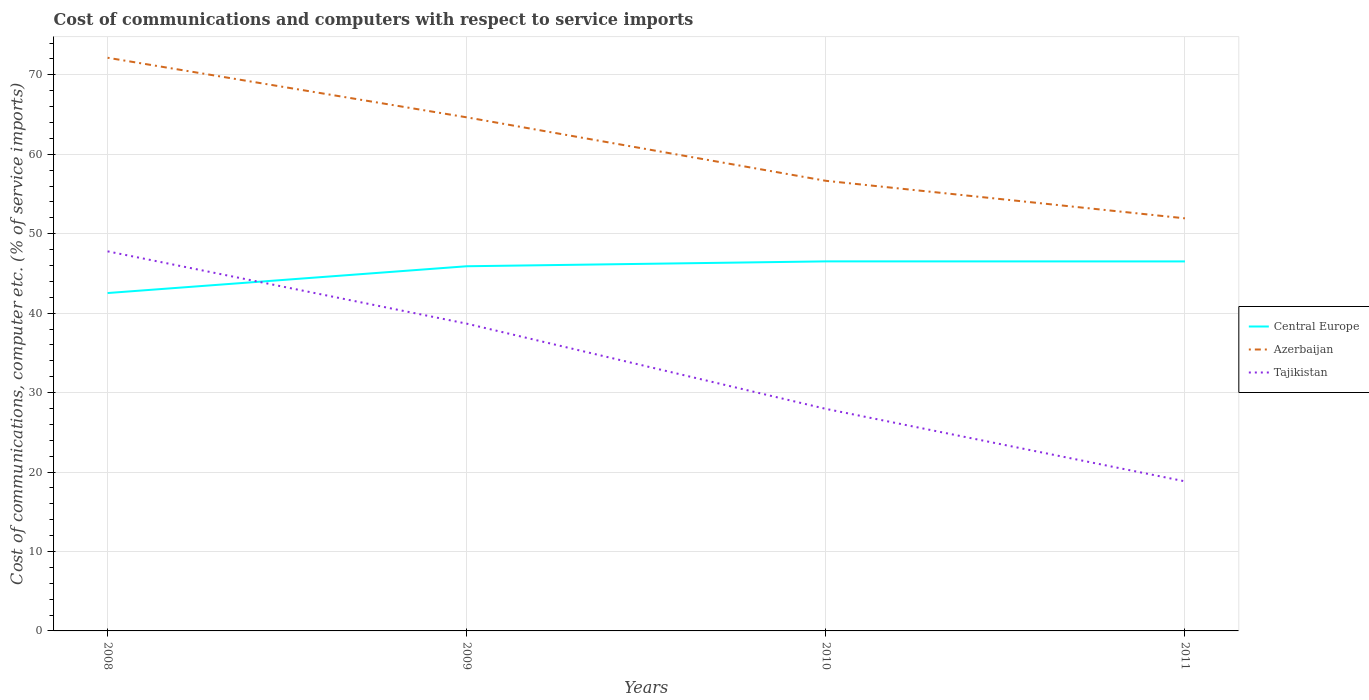How many different coloured lines are there?
Provide a succinct answer. 3. Across all years, what is the maximum cost of communications and computers in Azerbaijan?
Your answer should be very brief. 51.94. In which year was the cost of communications and computers in Tajikistan maximum?
Your answer should be compact. 2011. What is the total cost of communications and computers in Tajikistan in the graph?
Make the answer very short. 10.73. What is the difference between the highest and the second highest cost of communications and computers in Tajikistan?
Provide a succinct answer. 28.95. What is the difference between the highest and the lowest cost of communications and computers in Central Europe?
Give a very brief answer. 3. Is the cost of communications and computers in Central Europe strictly greater than the cost of communications and computers in Tajikistan over the years?
Ensure brevity in your answer.  No. Are the values on the major ticks of Y-axis written in scientific E-notation?
Offer a terse response. No. Does the graph contain any zero values?
Offer a very short reply. No. Does the graph contain grids?
Give a very brief answer. Yes. Where does the legend appear in the graph?
Make the answer very short. Center right. How are the legend labels stacked?
Provide a short and direct response. Vertical. What is the title of the graph?
Offer a terse response. Cost of communications and computers with respect to service imports. What is the label or title of the Y-axis?
Give a very brief answer. Cost of communications, computer etc. (% of service imports). What is the Cost of communications, computer etc. (% of service imports) of Central Europe in 2008?
Offer a terse response. 42.53. What is the Cost of communications, computer etc. (% of service imports) of Azerbaijan in 2008?
Ensure brevity in your answer.  72.15. What is the Cost of communications, computer etc. (% of service imports) in Tajikistan in 2008?
Provide a succinct answer. 47.78. What is the Cost of communications, computer etc. (% of service imports) in Central Europe in 2009?
Give a very brief answer. 45.9. What is the Cost of communications, computer etc. (% of service imports) of Azerbaijan in 2009?
Your response must be concise. 64.65. What is the Cost of communications, computer etc. (% of service imports) of Tajikistan in 2009?
Give a very brief answer. 38.68. What is the Cost of communications, computer etc. (% of service imports) of Central Europe in 2010?
Offer a very short reply. 46.52. What is the Cost of communications, computer etc. (% of service imports) in Azerbaijan in 2010?
Provide a short and direct response. 56.66. What is the Cost of communications, computer etc. (% of service imports) in Tajikistan in 2010?
Keep it short and to the point. 27.95. What is the Cost of communications, computer etc. (% of service imports) in Central Europe in 2011?
Your answer should be very brief. 46.51. What is the Cost of communications, computer etc. (% of service imports) in Azerbaijan in 2011?
Give a very brief answer. 51.94. What is the Cost of communications, computer etc. (% of service imports) in Tajikistan in 2011?
Your answer should be very brief. 18.83. Across all years, what is the maximum Cost of communications, computer etc. (% of service imports) in Central Europe?
Ensure brevity in your answer.  46.52. Across all years, what is the maximum Cost of communications, computer etc. (% of service imports) in Azerbaijan?
Offer a very short reply. 72.15. Across all years, what is the maximum Cost of communications, computer etc. (% of service imports) of Tajikistan?
Make the answer very short. 47.78. Across all years, what is the minimum Cost of communications, computer etc. (% of service imports) of Central Europe?
Your response must be concise. 42.53. Across all years, what is the minimum Cost of communications, computer etc. (% of service imports) of Azerbaijan?
Your response must be concise. 51.94. Across all years, what is the minimum Cost of communications, computer etc. (% of service imports) of Tajikistan?
Make the answer very short. 18.83. What is the total Cost of communications, computer etc. (% of service imports) in Central Europe in the graph?
Offer a very short reply. 181.46. What is the total Cost of communications, computer etc. (% of service imports) in Azerbaijan in the graph?
Give a very brief answer. 245.39. What is the total Cost of communications, computer etc. (% of service imports) in Tajikistan in the graph?
Make the answer very short. 133.24. What is the difference between the Cost of communications, computer etc. (% of service imports) of Central Europe in 2008 and that in 2009?
Provide a short and direct response. -3.37. What is the difference between the Cost of communications, computer etc. (% of service imports) in Azerbaijan in 2008 and that in 2009?
Keep it short and to the point. 7.5. What is the difference between the Cost of communications, computer etc. (% of service imports) in Tajikistan in 2008 and that in 2009?
Your answer should be very brief. 9.1. What is the difference between the Cost of communications, computer etc. (% of service imports) of Central Europe in 2008 and that in 2010?
Provide a succinct answer. -3.99. What is the difference between the Cost of communications, computer etc. (% of service imports) of Azerbaijan in 2008 and that in 2010?
Give a very brief answer. 15.49. What is the difference between the Cost of communications, computer etc. (% of service imports) in Tajikistan in 2008 and that in 2010?
Give a very brief answer. 19.83. What is the difference between the Cost of communications, computer etc. (% of service imports) of Central Europe in 2008 and that in 2011?
Make the answer very short. -3.98. What is the difference between the Cost of communications, computer etc. (% of service imports) in Azerbaijan in 2008 and that in 2011?
Offer a very short reply. 20.21. What is the difference between the Cost of communications, computer etc. (% of service imports) in Tajikistan in 2008 and that in 2011?
Provide a short and direct response. 28.95. What is the difference between the Cost of communications, computer etc. (% of service imports) of Central Europe in 2009 and that in 2010?
Your answer should be very brief. -0.61. What is the difference between the Cost of communications, computer etc. (% of service imports) of Azerbaijan in 2009 and that in 2010?
Give a very brief answer. 7.99. What is the difference between the Cost of communications, computer etc. (% of service imports) in Tajikistan in 2009 and that in 2010?
Give a very brief answer. 10.73. What is the difference between the Cost of communications, computer etc. (% of service imports) in Central Europe in 2009 and that in 2011?
Make the answer very short. -0.61. What is the difference between the Cost of communications, computer etc. (% of service imports) of Azerbaijan in 2009 and that in 2011?
Provide a succinct answer. 12.71. What is the difference between the Cost of communications, computer etc. (% of service imports) of Tajikistan in 2009 and that in 2011?
Keep it short and to the point. 19.85. What is the difference between the Cost of communications, computer etc. (% of service imports) of Central Europe in 2010 and that in 2011?
Give a very brief answer. 0.01. What is the difference between the Cost of communications, computer etc. (% of service imports) of Azerbaijan in 2010 and that in 2011?
Provide a short and direct response. 4.72. What is the difference between the Cost of communications, computer etc. (% of service imports) of Tajikistan in 2010 and that in 2011?
Your answer should be very brief. 9.12. What is the difference between the Cost of communications, computer etc. (% of service imports) in Central Europe in 2008 and the Cost of communications, computer etc. (% of service imports) in Azerbaijan in 2009?
Your answer should be very brief. -22.12. What is the difference between the Cost of communications, computer etc. (% of service imports) in Central Europe in 2008 and the Cost of communications, computer etc. (% of service imports) in Tajikistan in 2009?
Your answer should be compact. 3.85. What is the difference between the Cost of communications, computer etc. (% of service imports) in Azerbaijan in 2008 and the Cost of communications, computer etc. (% of service imports) in Tajikistan in 2009?
Provide a short and direct response. 33.47. What is the difference between the Cost of communications, computer etc. (% of service imports) of Central Europe in 2008 and the Cost of communications, computer etc. (% of service imports) of Azerbaijan in 2010?
Your answer should be very brief. -14.13. What is the difference between the Cost of communications, computer etc. (% of service imports) in Central Europe in 2008 and the Cost of communications, computer etc. (% of service imports) in Tajikistan in 2010?
Ensure brevity in your answer.  14.58. What is the difference between the Cost of communications, computer etc. (% of service imports) in Azerbaijan in 2008 and the Cost of communications, computer etc. (% of service imports) in Tajikistan in 2010?
Make the answer very short. 44.2. What is the difference between the Cost of communications, computer etc. (% of service imports) of Central Europe in 2008 and the Cost of communications, computer etc. (% of service imports) of Azerbaijan in 2011?
Make the answer very short. -9.4. What is the difference between the Cost of communications, computer etc. (% of service imports) in Central Europe in 2008 and the Cost of communications, computer etc. (% of service imports) in Tajikistan in 2011?
Offer a very short reply. 23.7. What is the difference between the Cost of communications, computer etc. (% of service imports) in Azerbaijan in 2008 and the Cost of communications, computer etc. (% of service imports) in Tajikistan in 2011?
Your answer should be compact. 53.32. What is the difference between the Cost of communications, computer etc. (% of service imports) in Central Europe in 2009 and the Cost of communications, computer etc. (% of service imports) in Azerbaijan in 2010?
Your answer should be very brief. -10.76. What is the difference between the Cost of communications, computer etc. (% of service imports) of Central Europe in 2009 and the Cost of communications, computer etc. (% of service imports) of Tajikistan in 2010?
Give a very brief answer. 17.95. What is the difference between the Cost of communications, computer etc. (% of service imports) of Azerbaijan in 2009 and the Cost of communications, computer etc. (% of service imports) of Tajikistan in 2010?
Offer a very short reply. 36.7. What is the difference between the Cost of communications, computer etc. (% of service imports) of Central Europe in 2009 and the Cost of communications, computer etc. (% of service imports) of Azerbaijan in 2011?
Ensure brevity in your answer.  -6.03. What is the difference between the Cost of communications, computer etc. (% of service imports) of Central Europe in 2009 and the Cost of communications, computer etc. (% of service imports) of Tajikistan in 2011?
Provide a short and direct response. 27.08. What is the difference between the Cost of communications, computer etc. (% of service imports) of Azerbaijan in 2009 and the Cost of communications, computer etc. (% of service imports) of Tajikistan in 2011?
Offer a terse response. 45.82. What is the difference between the Cost of communications, computer etc. (% of service imports) in Central Europe in 2010 and the Cost of communications, computer etc. (% of service imports) in Azerbaijan in 2011?
Your answer should be compact. -5.42. What is the difference between the Cost of communications, computer etc. (% of service imports) in Central Europe in 2010 and the Cost of communications, computer etc. (% of service imports) in Tajikistan in 2011?
Provide a succinct answer. 27.69. What is the difference between the Cost of communications, computer etc. (% of service imports) of Azerbaijan in 2010 and the Cost of communications, computer etc. (% of service imports) of Tajikistan in 2011?
Keep it short and to the point. 37.83. What is the average Cost of communications, computer etc. (% of service imports) in Central Europe per year?
Offer a terse response. 45.37. What is the average Cost of communications, computer etc. (% of service imports) of Azerbaijan per year?
Ensure brevity in your answer.  61.35. What is the average Cost of communications, computer etc. (% of service imports) of Tajikistan per year?
Make the answer very short. 33.31. In the year 2008, what is the difference between the Cost of communications, computer etc. (% of service imports) in Central Europe and Cost of communications, computer etc. (% of service imports) in Azerbaijan?
Offer a very short reply. -29.62. In the year 2008, what is the difference between the Cost of communications, computer etc. (% of service imports) in Central Europe and Cost of communications, computer etc. (% of service imports) in Tajikistan?
Ensure brevity in your answer.  -5.25. In the year 2008, what is the difference between the Cost of communications, computer etc. (% of service imports) of Azerbaijan and Cost of communications, computer etc. (% of service imports) of Tajikistan?
Make the answer very short. 24.37. In the year 2009, what is the difference between the Cost of communications, computer etc. (% of service imports) in Central Europe and Cost of communications, computer etc. (% of service imports) in Azerbaijan?
Ensure brevity in your answer.  -18.74. In the year 2009, what is the difference between the Cost of communications, computer etc. (% of service imports) in Central Europe and Cost of communications, computer etc. (% of service imports) in Tajikistan?
Give a very brief answer. 7.22. In the year 2009, what is the difference between the Cost of communications, computer etc. (% of service imports) of Azerbaijan and Cost of communications, computer etc. (% of service imports) of Tajikistan?
Keep it short and to the point. 25.97. In the year 2010, what is the difference between the Cost of communications, computer etc. (% of service imports) of Central Europe and Cost of communications, computer etc. (% of service imports) of Azerbaijan?
Offer a terse response. -10.14. In the year 2010, what is the difference between the Cost of communications, computer etc. (% of service imports) in Central Europe and Cost of communications, computer etc. (% of service imports) in Tajikistan?
Offer a very short reply. 18.57. In the year 2010, what is the difference between the Cost of communications, computer etc. (% of service imports) in Azerbaijan and Cost of communications, computer etc. (% of service imports) in Tajikistan?
Offer a terse response. 28.71. In the year 2011, what is the difference between the Cost of communications, computer etc. (% of service imports) in Central Europe and Cost of communications, computer etc. (% of service imports) in Azerbaijan?
Provide a short and direct response. -5.42. In the year 2011, what is the difference between the Cost of communications, computer etc. (% of service imports) of Central Europe and Cost of communications, computer etc. (% of service imports) of Tajikistan?
Your answer should be very brief. 27.68. In the year 2011, what is the difference between the Cost of communications, computer etc. (% of service imports) in Azerbaijan and Cost of communications, computer etc. (% of service imports) in Tajikistan?
Your answer should be very brief. 33.11. What is the ratio of the Cost of communications, computer etc. (% of service imports) of Central Europe in 2008 to that in 2009?
Offer a terse response. 0.93. What is the ratio of the Cost of communications, computer etc. (% of service imports) in Azerbaijan in 2008 to that in 2009?
Keep it short and to the point. 1.12. What is the ratio of the Cost of communications, computer etc. (% of service imports) in Tajikistan in 2008 to that in 2009?
Provide a short and direct response. 1.24. What is the ratio of the Cost of communications, computer etc. (% of service imports) of Central Europe in 2008 to that in 2010?
Your answer should be very brief. 0.91. What is the ratio of the Cost of communications, computer etc. (% of service imports) of Azerbaijan in 2008 to that in 2010?
Keep it short and to the point. 1.27. What is the ratio of the Cost of communications, computer etc. (% of service imports) of Tajikistan in 2008 to that in 2010?
Your response must be concise. 1.71. What is the ratio of the Cost of communications, computer etc. (% of service imports) of Central Europe in 2008 to that in 2011?
Ensure brevity in your answer.  0.91. What is the ratio of the Cost of communications, computer etc. (% of service imports) of Azerbaijan in 2008 to that in 2011?
Give a very brief answer. 1.39. What is the ratio of the Cost of communications, computer etc. (% of service imports) of Tajikistan in 2008 to that in 2011?
Provide a succinct answer. 2.54. What is the ratio of the Cost of communications, computer etc. (% of service imports) of Central Europe in 2009 to that in 2010?
Your answer should be compact. 0.99. What is the ratio of the Cost of communications, computer etc. (% of service imports) of Azerbaijan in 2009 to that in 2010?
Keep it short and to the point. 1.14. What is the ratio of the Cost of communications, computer etc. (% of service imports) in Tajikistan in 2009 to that in 2010?
Make the answer very short. 1.38. What is the ratio of the Cost of communications, computer etc. (% of service imports) in Central Europe in 2009 to that in 2011?
Make the answer very short. 0.99. What is the ratio of the Cost of communications, computer etc. (% of service imports) in Azerbaijan in 2009 to that in 2011?
Provide a succinct answer. 1.24. What is the ratio of the Cost of communications, computer etc. (% of service imports) in Tajikistan in 2009 to that in 2011?
Your answer should be compact. 2.05. What is the ratio of the Cost of communications, computer etc. (% of service imports) of Azerbaijan in 2010 to that in 2011?
Keep it short and to the point. 1.09. What is the ratio of the Cost of communications, computer etc. (% of service imports) in Tajikistan in 2010 to that in 2011?
Your answer should be compact. 1.48. What is the difference between the highest and the second highest Cost of communications, computer etc. (% of service imports) of Central Europe?
Offer a terse response. 0.01. What is the difference between the highest and the second highest Cost of communications, computer etc. (% of service imports) of Azerbaijan?
Give a very brief answer. 7.5. What is the difference between the highest and the second highest Cost of communications, computer etc. (% of service imports) in Tajikistan?
Your answer should be very brief. 9.1. What is the difference between the highest and the lowest Cost of communications, computer etc. (% of service imports) of Central Europe?
Offer a very short reply. 3.99. What is the difference between the highest and the lowest Cost of communications, computer etc. (% of service imports) of Azerbaijan?
Make the answer very short. 20.21. What is the difference between the highest and the lowest Cost of communications, computer etc. (% of service imports) in Tajikistan?
Keep it short and to the point. 28.95. 